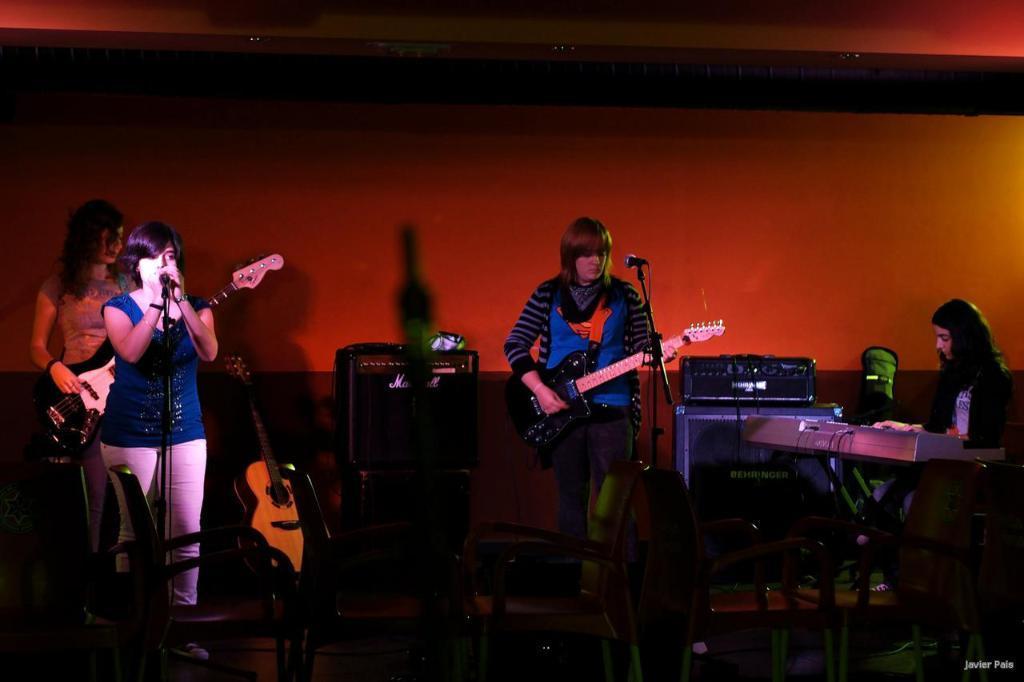Please provide a concise description of this image. This woman is singing in-front of mic. These two womens are playing guitar. 